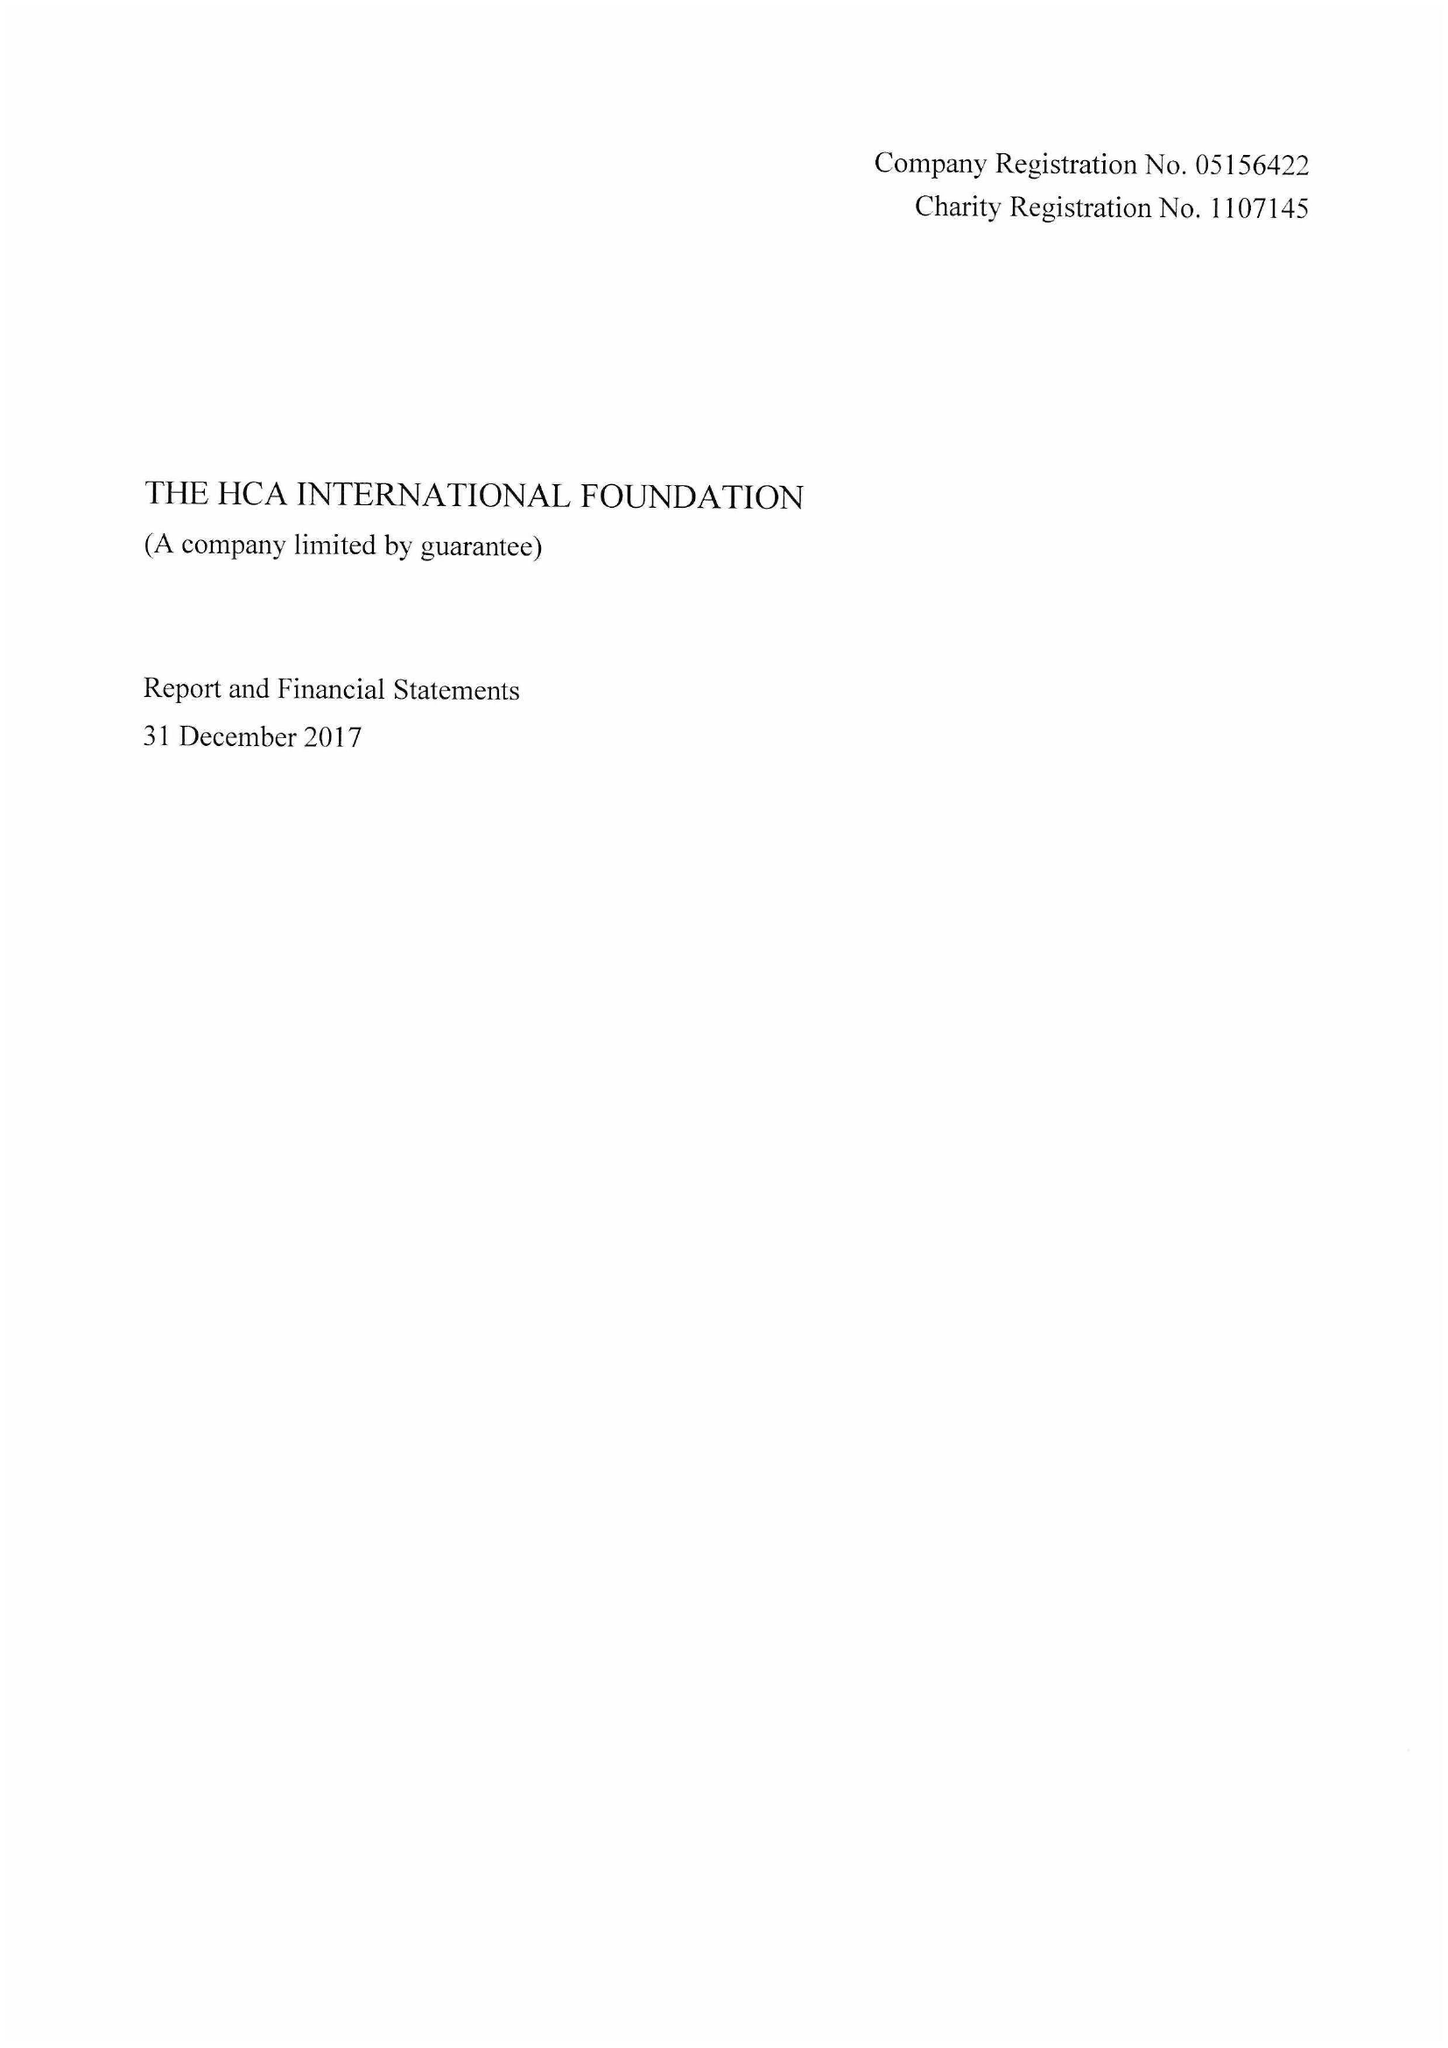What is the value for the address__street_line?
Answer the question using a single word or phrase. 242-246 MARYLEBONE ROAD 